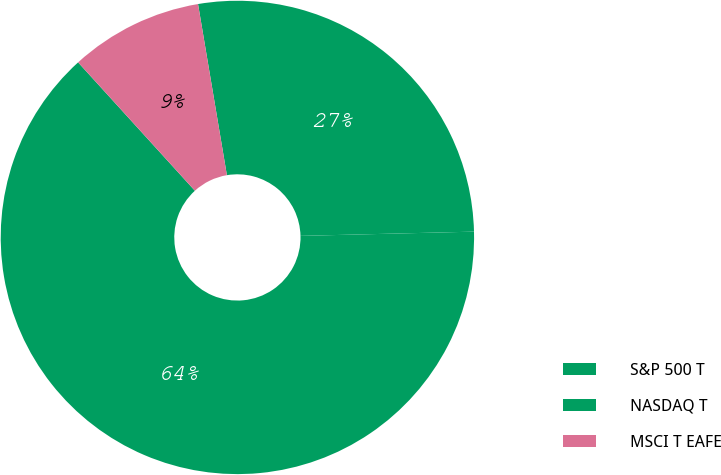<chart> <loc_0><loc_0><loc_500><loc_500><pie_chart><fcel>S&P 500 T<fcel>NASDAQ T<fcel>MSCI T EAFE<nl><fcel>27.27%<fcel>63.64%<fcel>9.09%<nl></chart> 